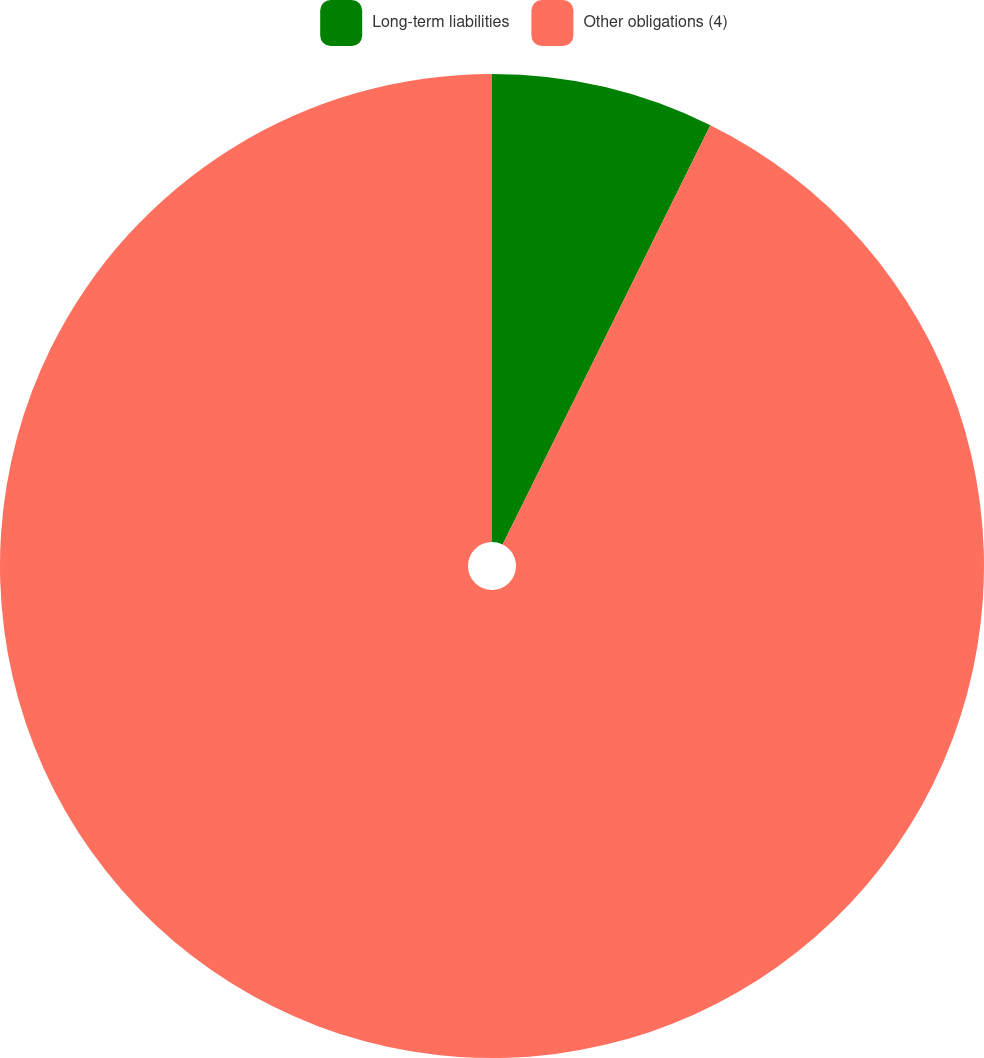<chart> <loc_0><loc_0><loc_500><loc_500><pie_chart><fcel>Long-term liabilities<fcel>Other obligations (4)<nl><fcel>7.32%<fcel>92.68%<nl></chart> 